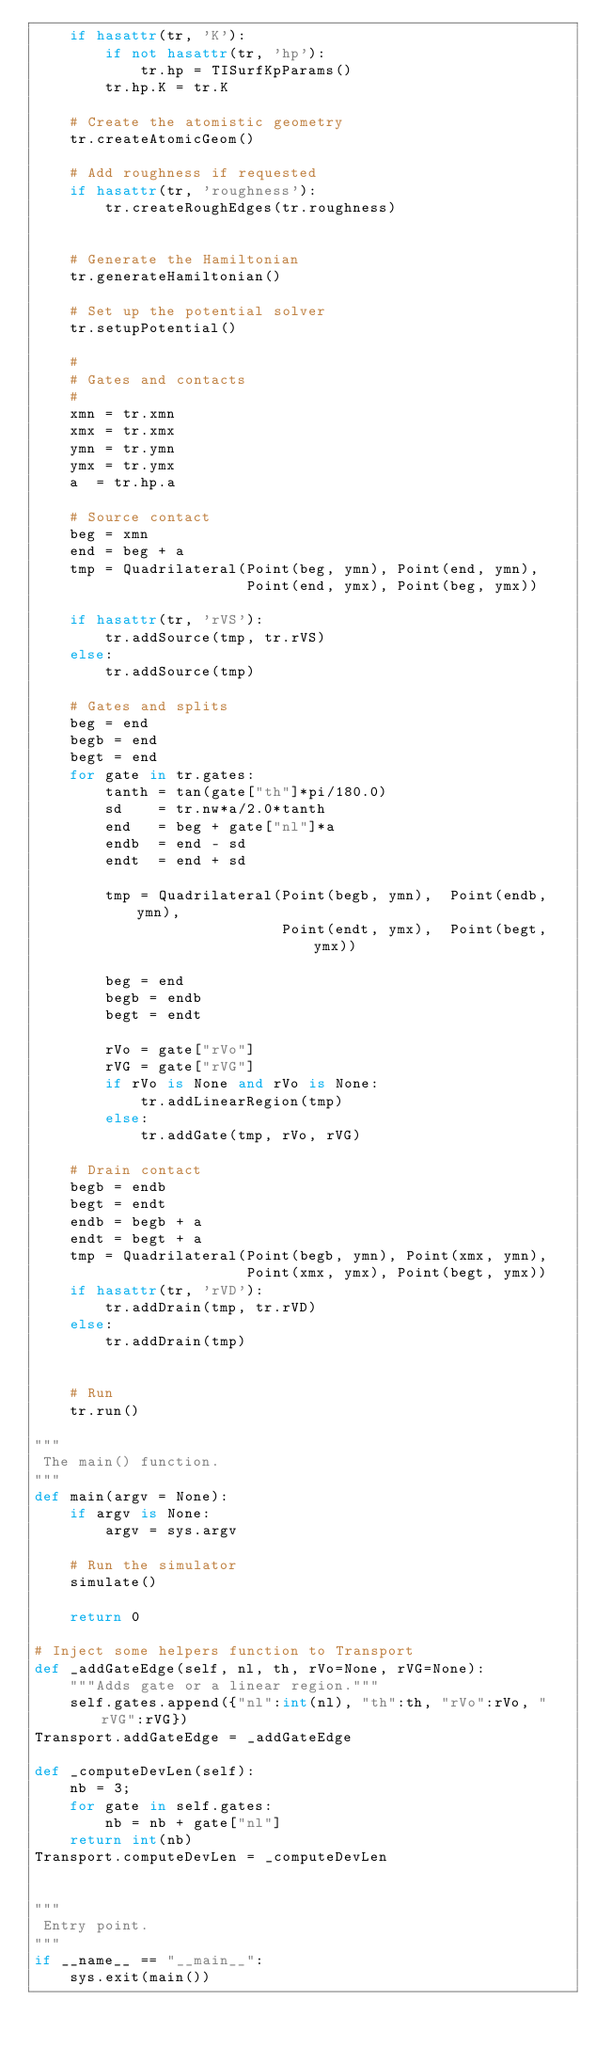Convert code to text. <code><loc_0><loc_0><loc_500><loc_500><_Python_>    if hasattr(tr, 'K'):
        if not hasattr(tr, 'hp'):
            tr.hp = TISurfKpParams()
        tr.hp.K = tr.K
 
    # Create the atomistic geometry
    tr.createAtomicGeom()
    
    # Add roughness if requested
    if hasattr(tr, 'roughness'):    
        tr.createRoughEdges(tr.roughness)
    

    # Generate the Hamiltonian
    tr.generateHamiltonian()
    
    # Set up the potential solver
    tr.setupPotential()
    
    #
    # Gates and contacts
    #
    xmn = tr.xmn
    xmx = tr.xmx
    ymn = tr.ymn
    ymx = tr.ymx
    a  = tr.hp.a
    
    # Source contact    
    beg = xmn
    end = beg + a
    tmp = Quadrilateral(Point(beg, ymn), Point(end, ymn),
                        Point(end, ymx), Point(beg, ymx))

    if hasattr(tr, 'rVS'):
        tr.addSource(tmp, tr.rVS)
    else:
        tr.addSource(tmp)

    # Gates and splits
    beg = end
    begb = end
    begt = end
    for gate in tr.gates:
        tanth = tan(gate["th"]*pi/180.0)
        sd    = tr.nw*a/2.0*tanth
        end   = beg + gate["nl"]*a
        endb  = end - sd
        endt  = end + sd
        
        tmp = Quadrilateral(Point(begb, ymn),  Point(endb, ymn),
                            Point(endt, ymx),  Point(begt, ymx))
        
        beg = end
        begb = endb
        begt = endt

        rVo = gate["rVo"]
        rVG = gate["rVG"]
        if rVo is None and rVo is None:
            tr.addLinearRegion(tmp)
        else:
            tr.addGate(tmp, rVo, rVG)
            
    # Drain contact
    begb = endb
    begt = endt
    endb = begb + a
    endt = begt + a
    tmp = Quadrilateral(Point(begb, ymn), Point(xmx, ymn),
                        Point(xmx, ymx), Point(begt, ymx))
    if hasattr(tr, 'rVD'):
        tr.addDrain(tmp, tr.rVD)
    else:
        tr.addDrain(tmp)

            
    # Run
    tr.run()

"""
 The main() function.
"""
def main(argv = None):
    if argv is None:
        argv = sys.argv

    # Run the simulator
    simulate()
        
    return 0

# Inject some helpers function to Transport
def _addGateEdge(self, nl, th, rVo=None, rVG=None):
    """Adds gate or a linear region."""
    self.gates.append({"nl":int(nl), "th":th, "rVo":rVo, "rVG":rVG})
Transport.addGateEdge = _addGateEdge

def _computeDevLen(self):
    nb = 3;
    for gate in self.gates:
        nb = nb + gate["nl"]
    return int(nb)
Transport.computeDevLen = _computeDevLen


"""
 Entry point.
"""
if __name__ == "__main__":
    sys.exit(main())



</code> 